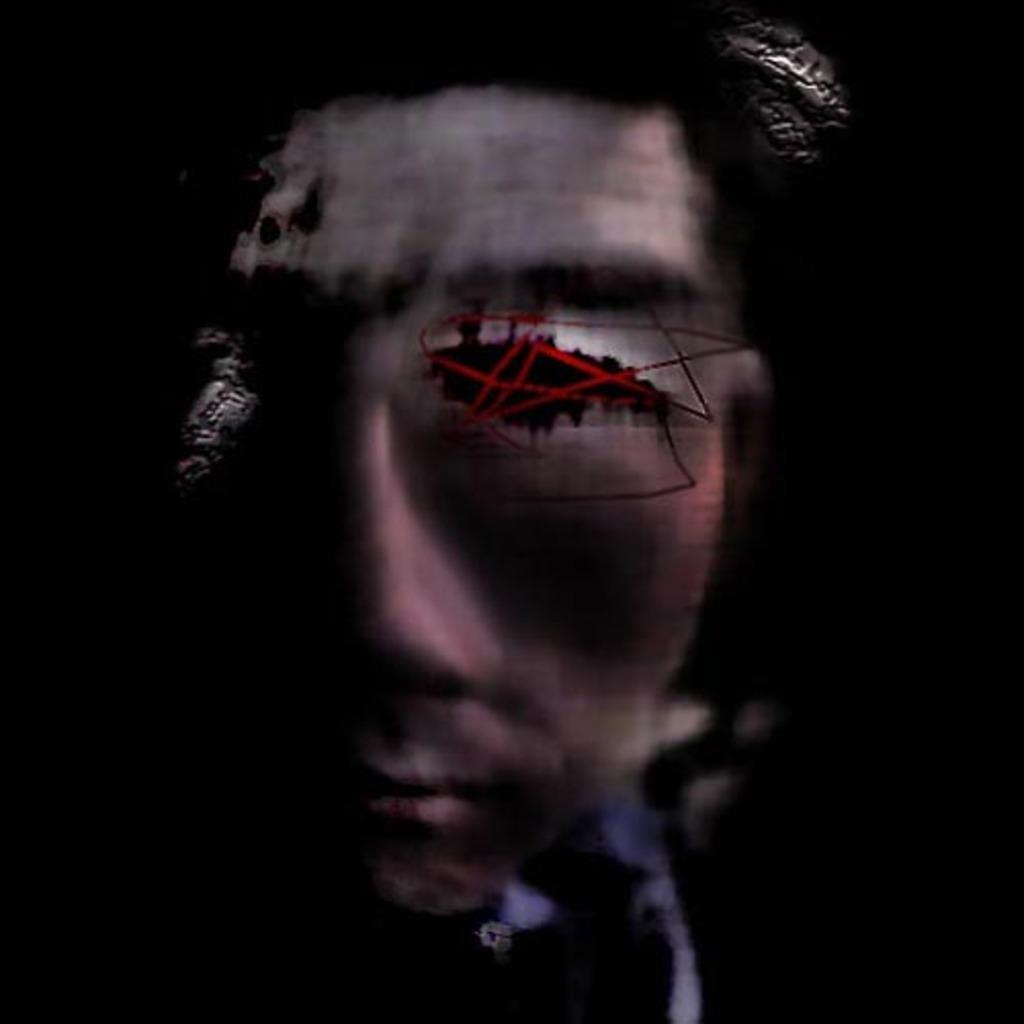What is the main subject of the picture? The main subject of the picture is a graphic. What is depicted in the graphic? The graphic contains the face of a person. What is the color of the background in the image? The background of the image is completely dark. What type of ship can be seen sailing in the background of the image? There is no ship present in the image; the background is completely dark. Can you tell me how many churches are visible in the image? There are no churches present in the image; it only contains a graphic with a person's face. 